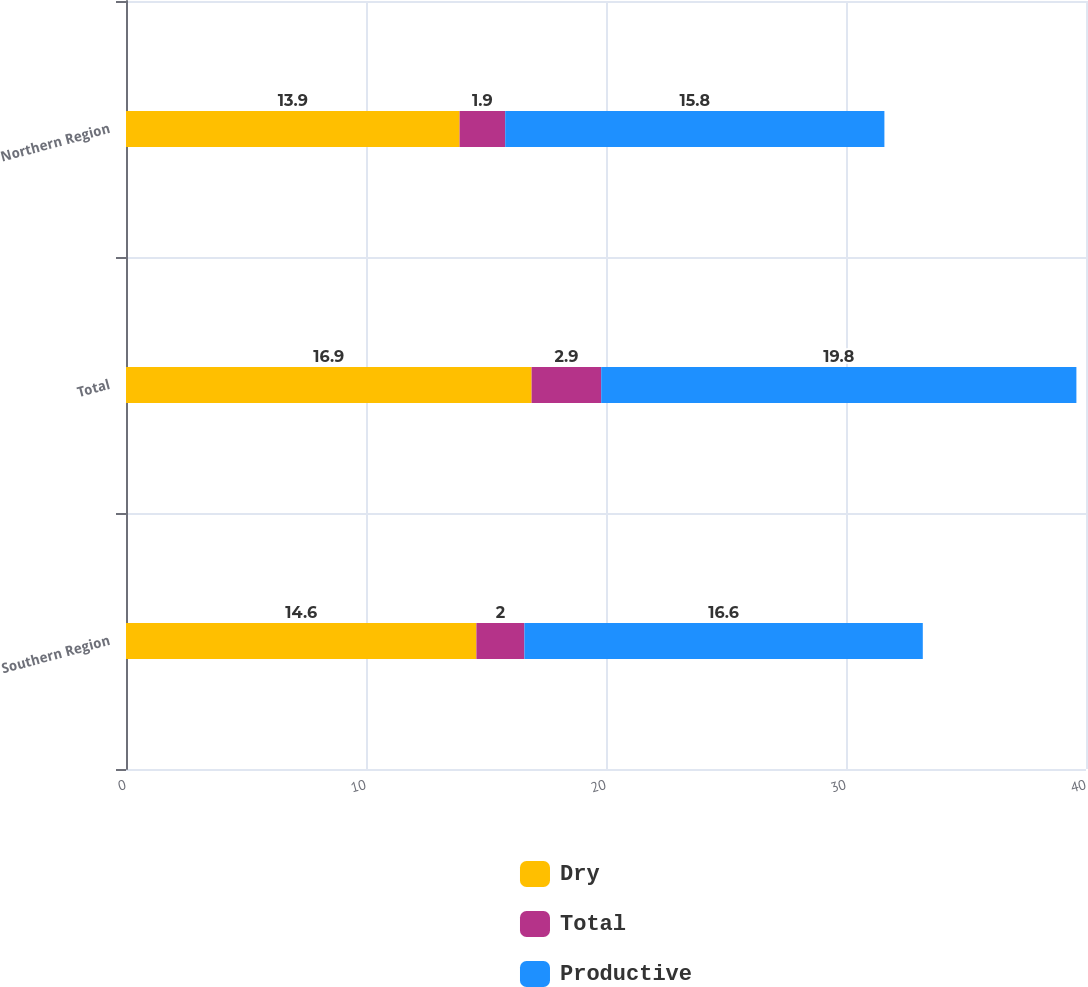Convert chart. <chart><loc_0><loc_0><loc_500><loc_500><stacked_bar_chart><ecel><fcel>Southern Region<fcel>Total<fcel>Northern Region<nl><fcel>Dry<fcel>14.6<fcel>16.9<fcel>13.9<nl><fcel>Total<fcel>2<fcel>2.9<fcel>1.9<nl><fcel>Productive<fcel>16.6<fcel>19.8<fcel>15.8<nl></chart> 